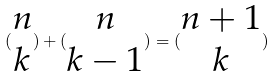<formula> <loc_0><loc_0><loc_500><loc_500>( \begin{matrix} n \\ k \end{matrix} ) + ( \begin{matrix} n \\ k - 1 \end{matrix} ) = ( \begin{matrix} n + 1 \\ k \end{matrix} )</formula> 